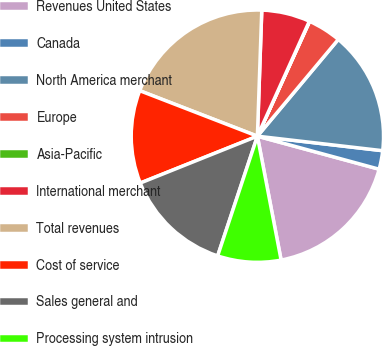Convert chart. <chart><loc_0><loc_0><loc_500><loc_500><pie_chart><fcel>Revenues United States<fcel>Canada<fcel>North America merchant<fcel>Europe<fcel>Asia-Pacific<fcel>International merchant<fcel>Total revenues<fcel>Cost of service<fcel>Sales general and<fcel>Processing system intrusion<nl><fcel>17.77%<fcel>2.38%<fcel>15.75%<fcel>4.29%<fcel>0.04%<fcel>6.2%<fcel>19.68%<fcel>11.93%<fcel>13.84%<fcel>8.11%<nl></chart> 